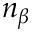<formula> <loc_0><loc_0><loc_500><loc_500>n _ { \beta }</formula> 